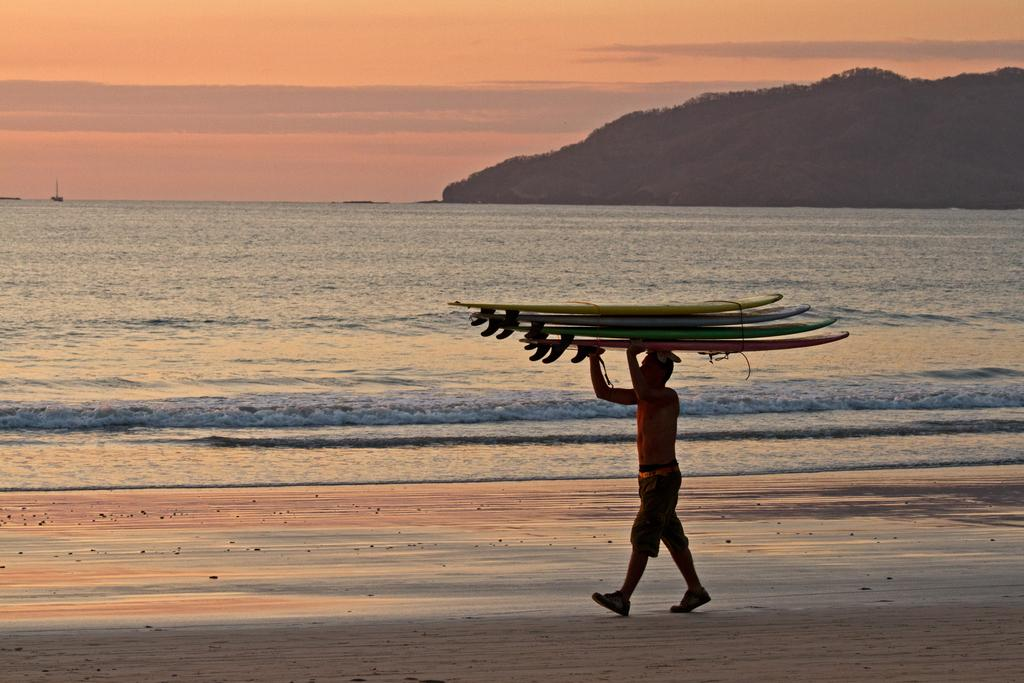Who is present in the image? There is a man in the image. What is the man doing in the image? The man is walking on a seashore. What is the man holding in the image? The man is holding something. What natural features can be seen in the image? There is a sea and mountains visible in the image. What part of the sky is visible in the image? The sky is visible in the image. What type of cave can be seen in the image? There is no cave present in the image. What is the cause of the man's footwear in the image? The image does not provide information about the man's footwear, so it is impossible to determine the cause. 